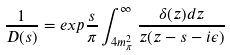<formula> <loc_0><loc_0><loc_500><loc_500>\frac { 1 } { D ( s ) } = e x p \frac { s } { \pi } \int _ { 4 m _ { \pi } ^ { 2 } } ^ { \infty } \frac { \delta ( z ) d z } { z ( z - s - i \epsilon ) }</formula> 